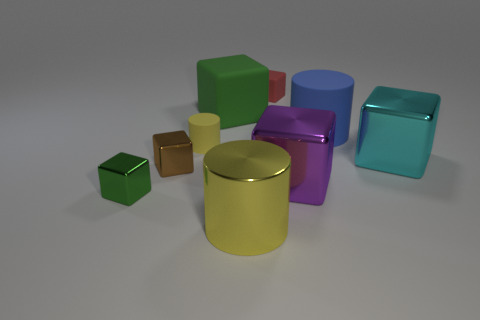Subtract all red blocks. How many blocks are left? 5 Subtract all cyan metallic blocks. How many blocks are left? 5 Subtract all gray cubes. Subtract all brown cylinders. How many cubes are left? 6 Subtract all cylinders. How many objects are left? 6 Subtract all small cyan matte objects. Subtract all cyan shiny objects. How many objects are left? 8 Add 7 large blue rubber objects. How many large blue rubber objects are left? 8 Add 6 big green cubes. How many big green cubes exist? 7 Subtract 0 blue spheres. How many objects are left? 9 